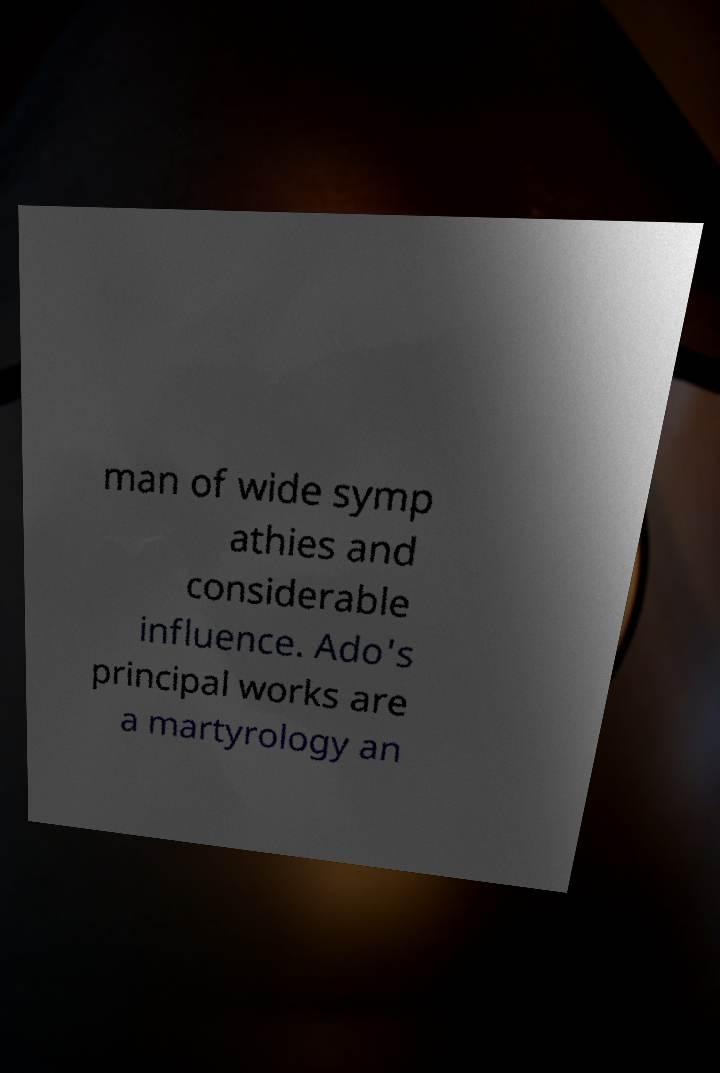For documentation purposes, I need the text within this image transcribed. Could you provide that? man of wide symp athies and considerable influence. Ado's principal works are a martyrology an 